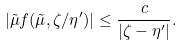<formula> <loc_0><loc_0><loc_500><loc_500>| \tilde { \mu } f ( \tilde { \mu } , \zeta / \eta ^ { \prime } ) | \leq \frac { c } { | \zeta - \eta ^ { \prime } | } .</formula> 